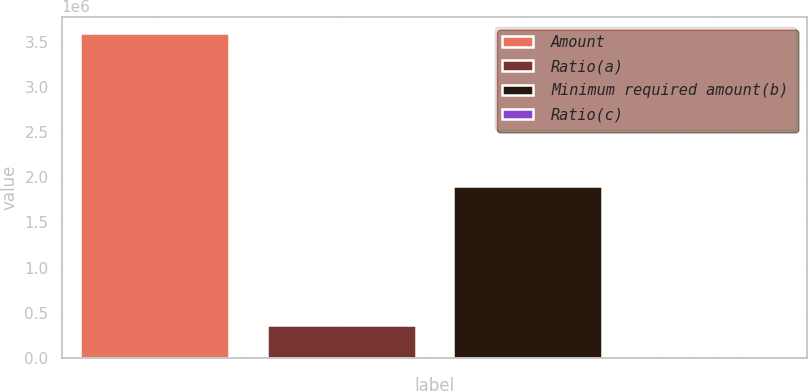Convert chart to OTSL. <chart><loc_0><loc_0><loc_500><loc_500><bar_chart><fcel>Amount<fcel>Ratio(a)<fcel>Minimum required amount(b)<fcel>Ratio(c)<nl><fcel>3.59883e+06<fcel>359889<fcel>1.90359e+06<fcel>6.94<nl></chart> 